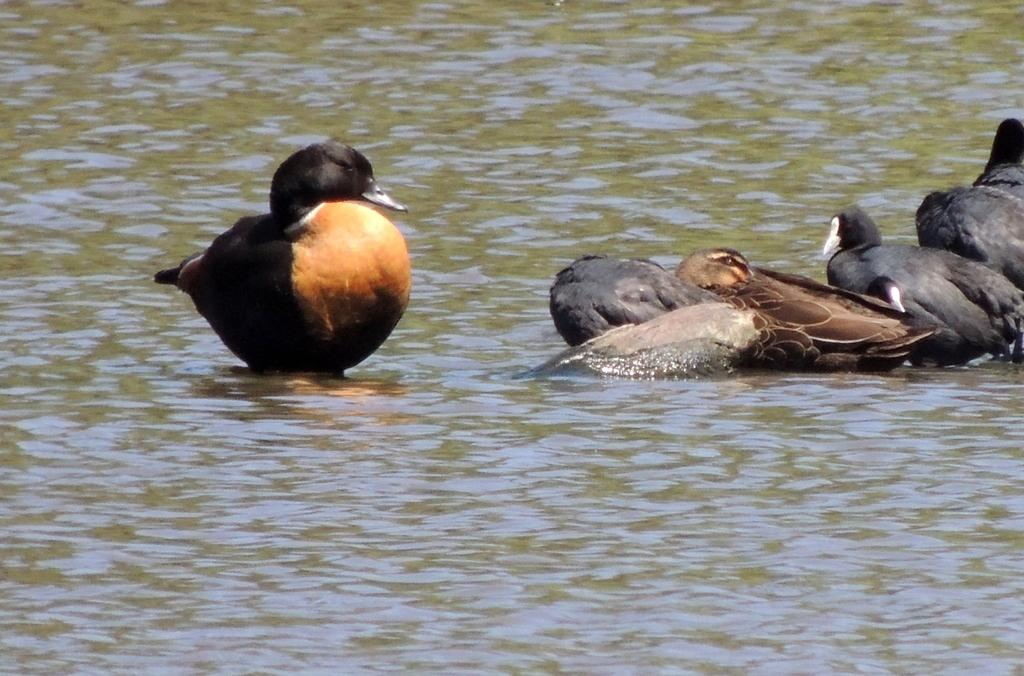What type of animals can be seen in the image? Birds can be seen in the image. Where are the birds situated in the image? The birds are situated in the water. How many legs can be seen on the yoke in the image? There is no yoke present in the image, and therefore no legs can be seen on it. 